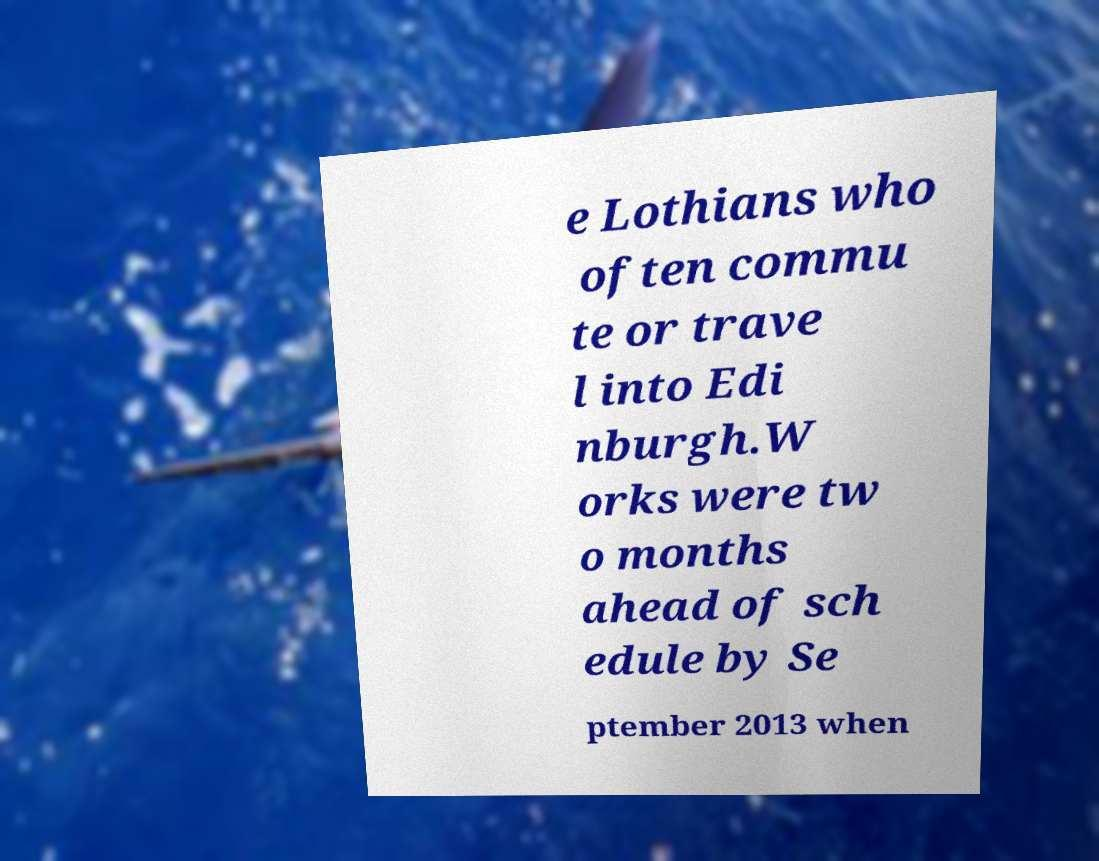Could you assist in decoding the text presented in this image and type it out clearly? e Lothians who often commu te or trave l into Edi nburgh.W orks were tw o months ahead of sch edule by Se ptember 2013 when 